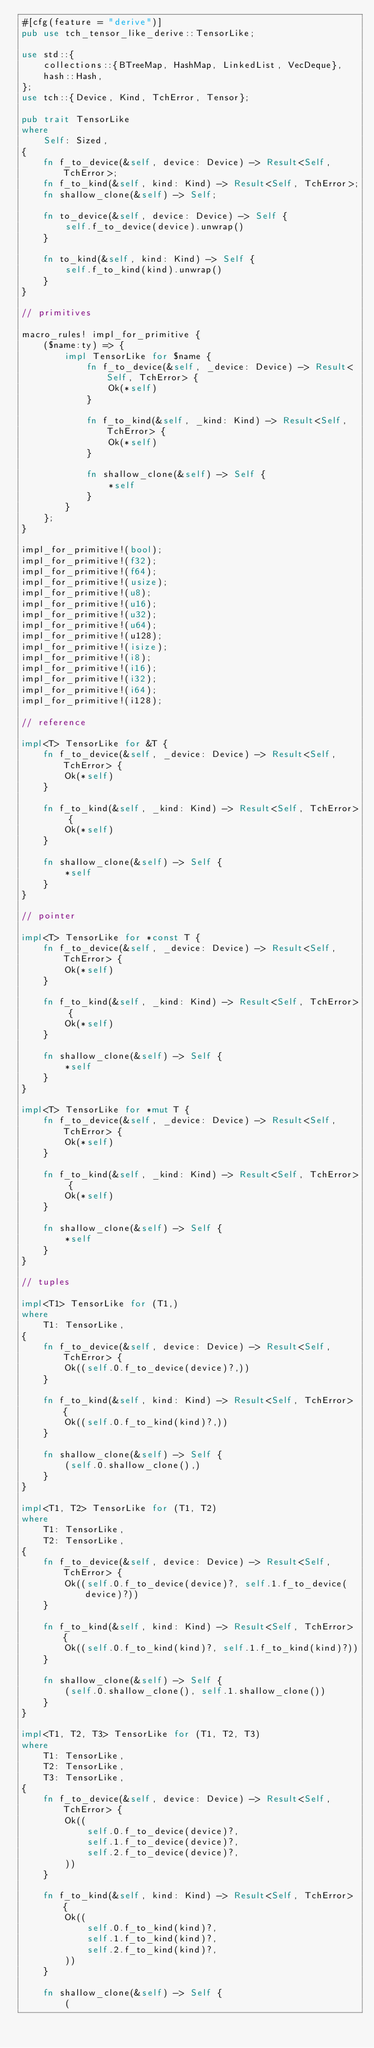Convert code to text. <code><loc_0><loc_0><loc_500><loc_500><_Rust_>#[cfg(feature = "derive")]
pub use tch_tensor_like_derive::TensorLike;

use std::{
    collections::{BTreeMap, HashMap, LinkedList, VecDeque},
    hash::Hash,
};
use tch::{Device, Kind, TchError, Tensor};

pub trait TensorLike
where
    Self: Sized,
{
    fn f_to_device(&self, device: Device) -> Result<Self, TchError>;
    fn f_to_kind(&self, kind: Kind) -> Result<Self, TchError>;
    fn shallow_clone(&self) -> Self;

    fn to_device(&self, device: Device) -> Self {
        self.f_to_device(device).unwrap()
    }

    fn to_kind(&self, kind: Kind) -> Self {
        self.f_to_kind(kind).unwrap()
    }
}

// primitives

macro_rules! impl_for_primitive {
    ($name:ty) => {
        impl TensorLike for $name {
            fn f_to_device(&self, _device: Device) -> Result<Self, TchError> {
                Ok(*self)
            }

            fn f_to_kind(&self, _kind: Kind) -> Result<Self, TchError> {
                Ok(*self)
            }

            fn shallow_clone(&self) -> Self {
                *self
            }
        }
    };
}

impl_for_primitive!(bool);
impl_for_primitive!(f32);
impl_for_primitive!(f64);
impl_for_primitive!(usize);
impl_for_primitive!(u8);
impl_for_primitive!(u16);
impl_for_primitive!(u32);
impl_for_primitive!(u64);
impl_for_primitive!(u128);
impl_for_primitive!(isize);
impl_for_primitive!(i8);
impl_for_primitive!(i16);
impl_for_primitive!(i32);
impl_for_primitive!(i64);
impl_for_primitive!(i128);

// reference

impl<T> TensorLike for &T {
    fn f_to_device(&self, _device: Device) -> Result<Self, TchError> {
        Ok(*self)
    }

    fn f_to_kind(&self, _kind: Kind) -> Result<Self, TchError> {
        Ok(*self)
    }

    fn shallow_clone(&self) -> Self {
        *self
    }
}

// pointer

impl<T> TensorLike for *const T {
    fn f_to_device(&self, _device: Device) -> Result<Self, TchError> {
        Ok(*self)
    }

    fn f_to_kind(&self, _kind: Kind) -> Result<Self, TchError> {
        Ok(*self)
    }

    fn shallow_clone(&self) -> Self {
        *self
    }
}

impl<T> TensorLike for *mut T {
    fn f_to_device(&self, _device: Device) -> Result<Self, TchError> {
        Ok(*self)
    }

    fn f_to_kind(&self, _kind: Kind) -> Result<Self, TchError> {
        Ok(*self)
    }

    fn shallow_clone(&self) -> Self {
        *self
    }
}

// tuples

impl<T1> TensorLike for (T1,)
where
    T1: TensorLike,
{
    fn f_to_device(&self, device: Device) -> Result<Self, TchError> {
        Ok((self.0.f_to_device(device)?,))
    }

    fn f_to_kind(&self, kind: Kind) -> Result<Self, TchError> {
        Ok((self.0.f_to_kind(kind)?,))
    }

    fn shallow_clone(&self) -> Self {
        (self.0.shallow_clone(),)
    }
}

impl<T1, T2> TensorLike for (T1, T2)
where
    T1: TensorLike,
    T2: TensorLike,
{
    fn f_to_device(&self, device: Device) -> Result<Self, TchError> {
        Ok((self.0.f_to_device(device)?, self.1.f_to_device(device)?))
    }

    fn f_to_kind(&self, kind: Kind) -> Result<Self, TchError> {
        Ok((self.0.f_to_kind(kind)?, self.1.f_to_kind(kind)?))
    }

    fn shallow_clone(&self) -> Self {
        (self.0.shallow_clone(), self.1.shallow_clone())
    }
}

impl<T1, T2, T3> TensorLike for (T1, T2, T3)
where
    T1: TensorLike,
    T2: TensorLike,
    T3: TensorLike,
{
    fn f_to_device(&self, device: Device) -> Result<Self, TchError> {
        Ok((
            self.0.f_to_device(device)?,
            self.1.f_to_device(device)?,
            self.2.f_to_device(device)?,
        ))
    }

    fn f_to_kind(&self, kind: Kind) -> Result<Self, TchError> {
        Ok((
            self.0.f_to_kind(kind)?,
            self.1.f_to_kind(kind)?,
            self.2.f_to_kind(kind)?,
        ))
    }

    fn shallow_clone(&self) -> Self {
        (</code> 